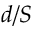Convert formula to latex. <formula><loc_0><loc_0><loc_500><loc_500>d / S</formula> 